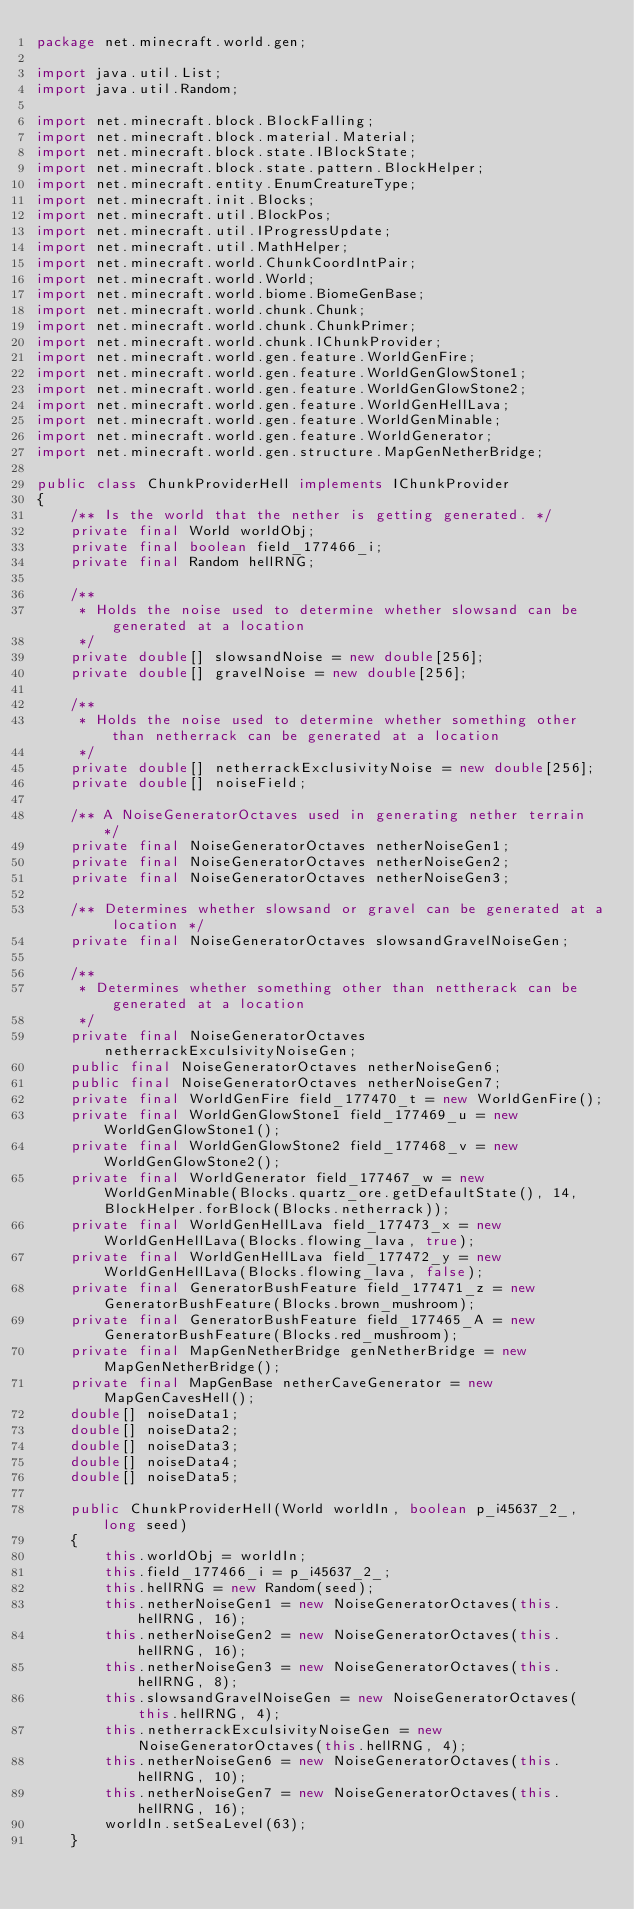Convert code to text. <code><loc_0><loc_0><loc_500><loc_500><_Java_>package net.minecraft.world.gen;

import java.util.List;
import java.util.Random;

import net.minecraft.block.BlockFalling;
import net.minecraft.block.material.Material;
import net.minecraft.block.state.IBlockState;
import net.minecraft.block.state.pattern.BlockHelper;
import net.minecraft.entity.EnumCreatureType;
import net.minecraft.init.Blocks;
import net.minecraft.util.BlockPos;
import net.minecraft.util.IProgressUpdate;
import net.minecraft.util.MathHelper;
import net.minecraft.world.ChunkCoordIntPair;
import net.minecraft.world.World;
import net.minecraft.world.biome.BiomeGenBase;
import net.minecraft.world.chunk.Chunk;
import net.minecraft.world.chunk.ChunkPrimer;
import net.minecraft.world.chunk.IChunkProvider;
import net.minecraft.world.gen.feature.WorldGenFire;
import net.minecraft.world.gen.feature.WorldGenGlowStone1;
import net.minecraft.world.gen.feature.WorldGenGlowStone2;
import net.minecraft.world.gen.feature.WorldGenHellLava;
import net.minecraft.world.gen.feature.WorldGenMinable;
import net.minecraft.world.gen.feature.WorldGenerator;
import net.minecraft.world.gen.structure.MapGenNetherBridge;

public class ChunkProviderHell implements IChunkProvider
{
    /** Is the world that the nether is getting generated. */
    private final World worldObj;
    private final boolean field_177466_i;
    private final Random hellRNG;

    /**
     * Holds the noise used to determine whether slowsand can be generated at a location
     */
    private double[] slowsandNoise = new double[256];
    private double[] gravelNoise = new double[256];

    /**
     * Holds the noise used to determine whether something other than netherrack can be generated at a location
     */
    private double[] netherrackExclusivityNoise = new double[256];
    private double[] noiseField;

    /** A NoiseGeneratorOctaves used in generating nether terrain */
    private final NoiseGeneratorOctaves netherNoiseGen1;
    private final NoiseGeneratorOctaves netherNoiseGen2;
    private final NoiseGeneratorOctaves netherNoiseGen3;

    /** Determines whether slowsand or gravel can be generated at a location */
    private final NoiseGeneratorOctaves slowsandGravelNoiseGen;

    /**
     * Determines whether something other than nettherack can be generated at a location
     */
    private final NoiseGeneratorOctaves netherrackExculsivityNoiseGen;
    public final NoiseGeneratorOctaves netherNoiseGen6;
    public final NoiseGeneratorOctaves netherNoiseGen7;
    private final WorldGenFire field_177470_t = new WorldGenFire();
    private final WorldGenGlowStone1 field_177469_u = new WorldGenGlowStone1();
    private final WorldGenGlowStone2 field_177468_v = new WorldGenGlowStone2();
    private final WorldGenerator field_177467_w = new WorldGenMinable(Blocks.quartz_ore.getDefaultState(), 14, BlockHelper.forBlock(Blocks.netherrack));
    private final WorldGenHellLava field_177473_x = new WorldGenHellLava(Blocks.flowing_lava, true);
    private final WorldGenHellLava field_177472_y = new WorldGenHellLava(Blocks.flowing_lava, false);
    private final GeneratorBushFeature field_177471_z = new GeneratorBushFeature(Blocks.brown_mushroom);
    private final GeneratorBushFeature field_177465_A = new GeneratorBushFeature(Blocks.red_mushroom);
    private final MapGenNetherBridge genNetherBridge = new MapGenNetherBridge();
    private final MapGenBase netherCaveGenerator = new MapGenCavesHell();
    double[] noiseData1;
    double[] noiseData2;
    double[] noiseData3;
    double[] noiseData4;
    double[] noiseData5;

    public ChunkProviderHell(World worldIn, boolean p_i45637_2_, long seed)
    {
        this.worldObj = worldIn;
        this.field_177466_i = p_i45637_2_;
        this.hellRNG = new Random(seed);
        this.netherNoiseGen1 = new NoiseGeneratorOctaves(this.hellRNG, 16);
        this.netherNoiseGen2 = new NoiseGeneratorOctaves(this.hellRNG, 16);
        this.netherNoiseGen3 = new NoiseGeneratorOctaves(this.hellRNG, 8);
        this.slowsandGravelNoiseGen = new NoiseGeneratorOctaves(this.hellRNG, 4);
        this.netherrackExculsivityNoiseGen = new NoiseGeneratorOctaves(this.hellRNG, 4);
        this.netherNoiseGen6 = new NoiseGeneratorOctaves(this.hellRNG, 10);
        this.netherNoiseGen7 = new NoiseGeneratorOctaves(this.hellRNG, 16);
        worldIn.setSeaLevel(63);
    }
</code> 